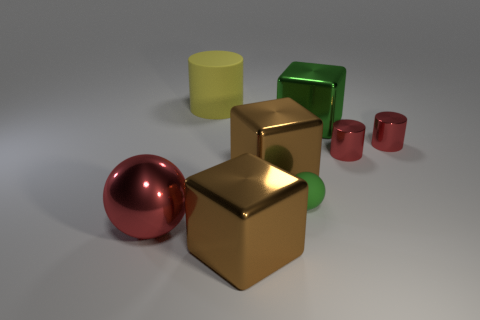What size is the other thing that is the same shape as the tiny green rubber thing?
Provide a succinct answer. Large. There is a tiny rubber ball; is it the same color as the big thing that is on the right side of the green matte ball?
Give a very brief answer. Yes. There is a brown block behind the large metallic thing that is in front of the metal sphere; what size is it?
Ensure brevity in your answer.  Large. What number of other things are there of the same color as the tiny ball?
Offer a very short reply. 1. Is the material of the tiny green sphere the same as the large green cube?
Ensure brevity in your answer.  No. Are there any purple metallic cubes of the same size as the red sphere?
Provide a short and direct response. No. There is a red sphere that is the same size as the green metallic object; what material is it?
Your answer should be very brief. Metal. Are there any large brown things of the same shape as the large green shiny object?
Keep it short and to the point. Yes. What is the shape of the brown object behind the shiny ball?
Offer a very short reply. Cube. How many green cubes are there?
Provide a short and direct response. 1. 